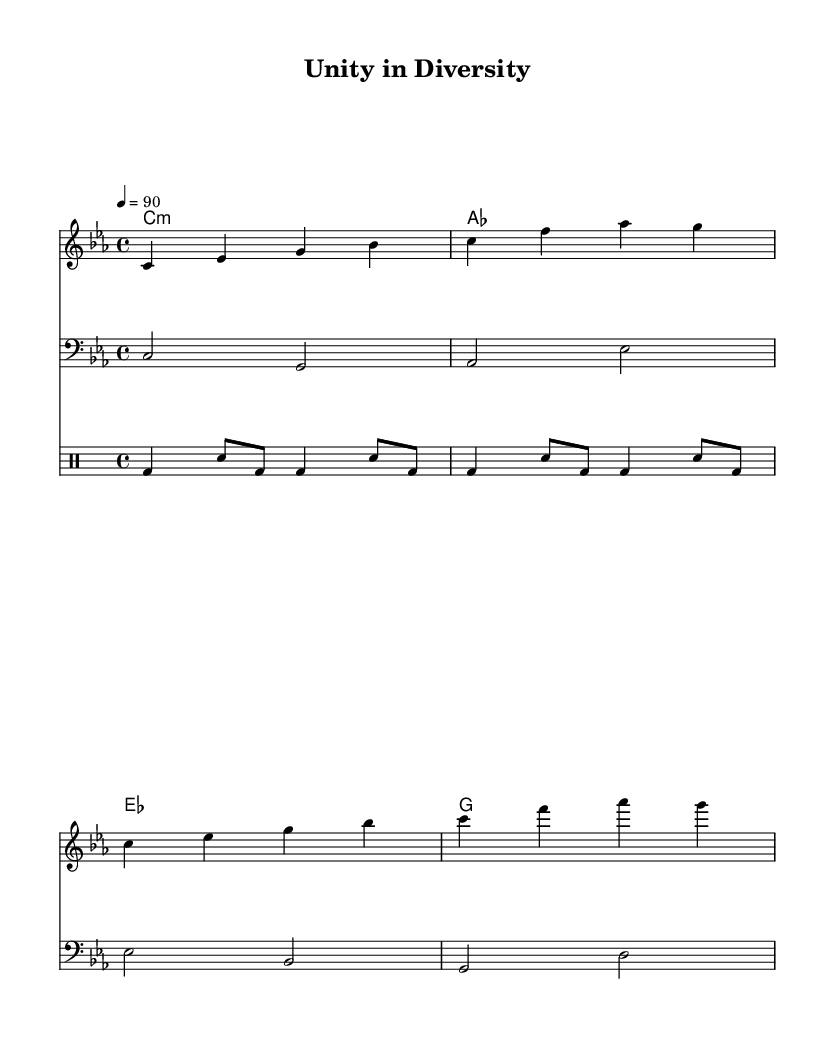What is the key signature of this music? The key signature is C minor, indicated by three flats (B-flat, E-flat, and A-flat). It is determined by looking at the beginning of the staff where the key signature is displayed.
Answer: C minor What is the time signature of this music? The time signature is 4/4, which can be found at the beginning of the sheet music, indicating that there are four beats per measure. This signature is commonly used in various music genres, including rap.
Answer: 4/4 What is the tempo marking for this music? The tempo marking is 4 = 90, meaning that the quarter note is set to 90 beats per minute. This information is placed above the staff indicating desired speed for performance.
Answer: 90 How many measures are in the chorus section? The chorus section consists of 4 measures as represented by four groups of notes divided by vertical lines (bar lines) in the sheet music.
Answer: 4 What type of musical composition is this? This composition is categorized as rap, as indicated by its lyrical focus on political critique, themes of religious extremism, and promotion of tolerance, which are common in rap music.
Answer: Rap What is the bass line progression? The bass line progression follows a specific pattern: C, G, A-flat, E-flat, E-flat, B-flat, G, D. This is deduced by analyzing the notes in the bass line indicated on the staff.
Answer: C, G, A-flat, E-flat Which rhythmic pattern is used in the drum section? The rhythmic pattern in the drum section primarily utilizes bass drum (bd) and snare (sn), structured in a repeating sequence that emphasizes the beat essential in rap music.
Answer: Bass and snare 